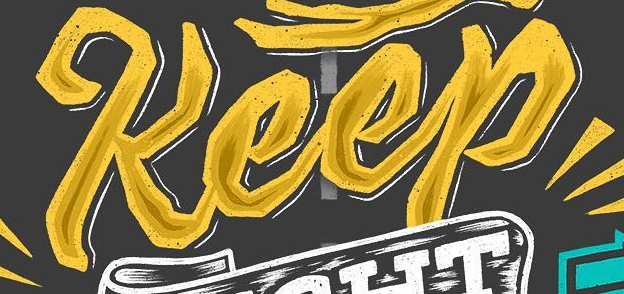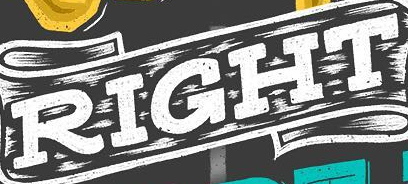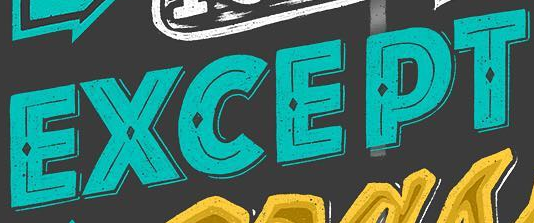What words can you see in these images in sequence, separated by a semicolon? Keep; RIGHT; EXCEPT 